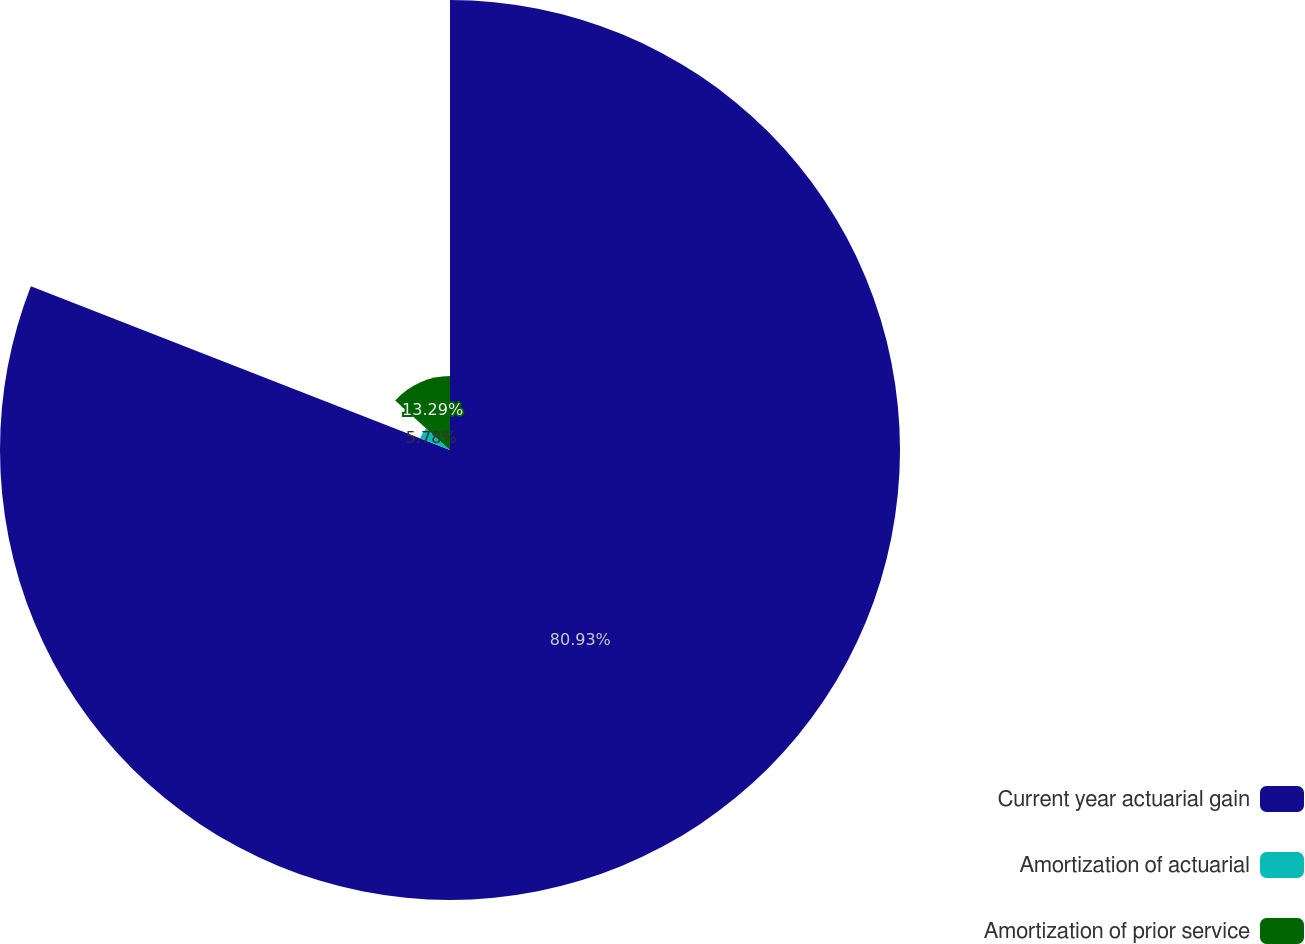<chart> <loc_0><loc_0><loc_500><loc_500><pie_chart><fcel>Current year actuarial gain<fcel>Amortization of actuarial<fcel>Amortization of prior service<nl><fcel>80.92%<fcel>5.78%<fcel>13.29%<nl></chart> 